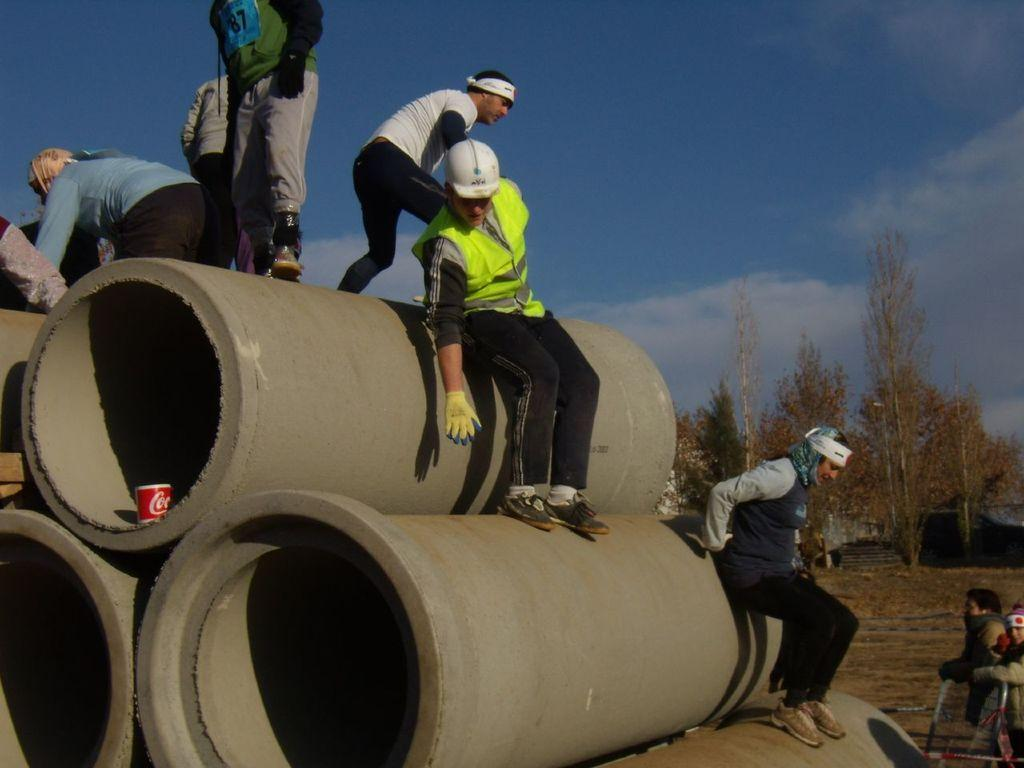What can be seen in the image? There are pipes in the image. Are there any people present in the image? Yes, there are people near the pipes. Can you describe the attire of one of the people? One person is wearing gloves and a helmet. What is visible in the background of the image? There are trees and the sky in the background of the image. What is the condition of the sky in the image? Clouds are present in the sky. What type of cough medicine is being taxed in the image? There is no mention of cough medicine or taxes in the image; it features pipes and people near them. Can you see a horse in the image? No, there is no horse present in the image. 